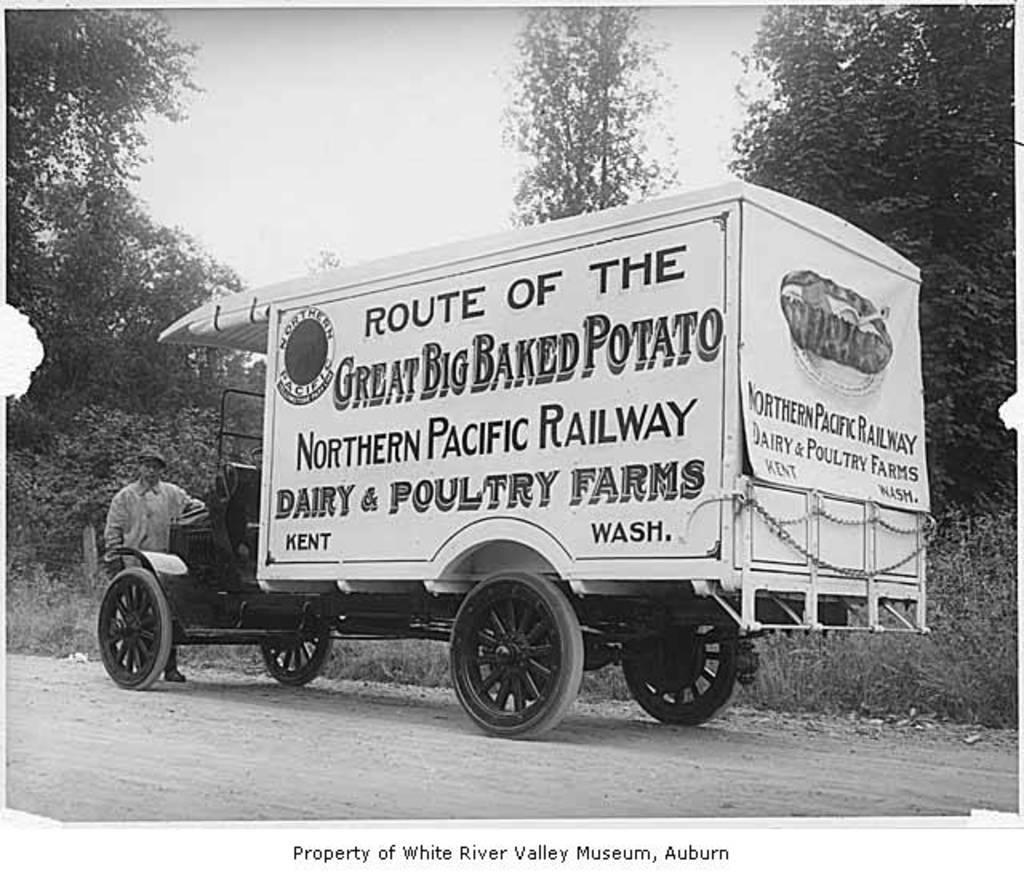How would you summarize this image in a sentence or two? In the foreground of this black and white image, there is a vehicle on the road and a man standing in front of it. In the background, there are trees and the sky. 